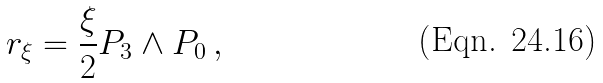<formula> <loc_0><loc_0><loc_500><loc_500>r _ { \xi } = \frac { \xi } { 2 } P _ { 3 } \wedge P _ { 0 } \, ,</formula> 